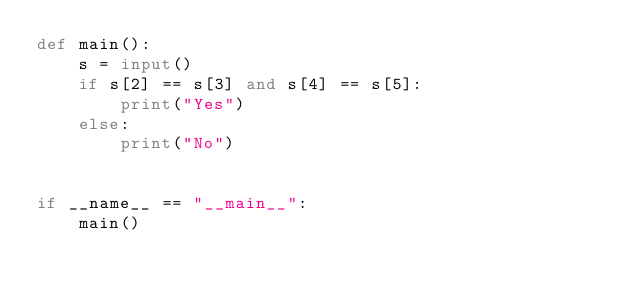Convert code to text. <code><loc_0><loc_0><loc_500><loc_500><_Python_>def main():
    s = input()
    if s[2] == s[3] and s[4] == s[5]:
        print("Yes")
    else:
        print("No")


if __name__ == "__main__":
    main()</code> 